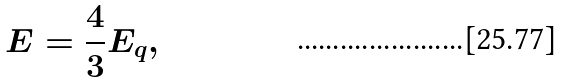Convert formula to latex. <formula><loc_0><loc_0><loc_500><loc_500>E = \frac { 4 } { 3 } E _ { q } ,</formula> 